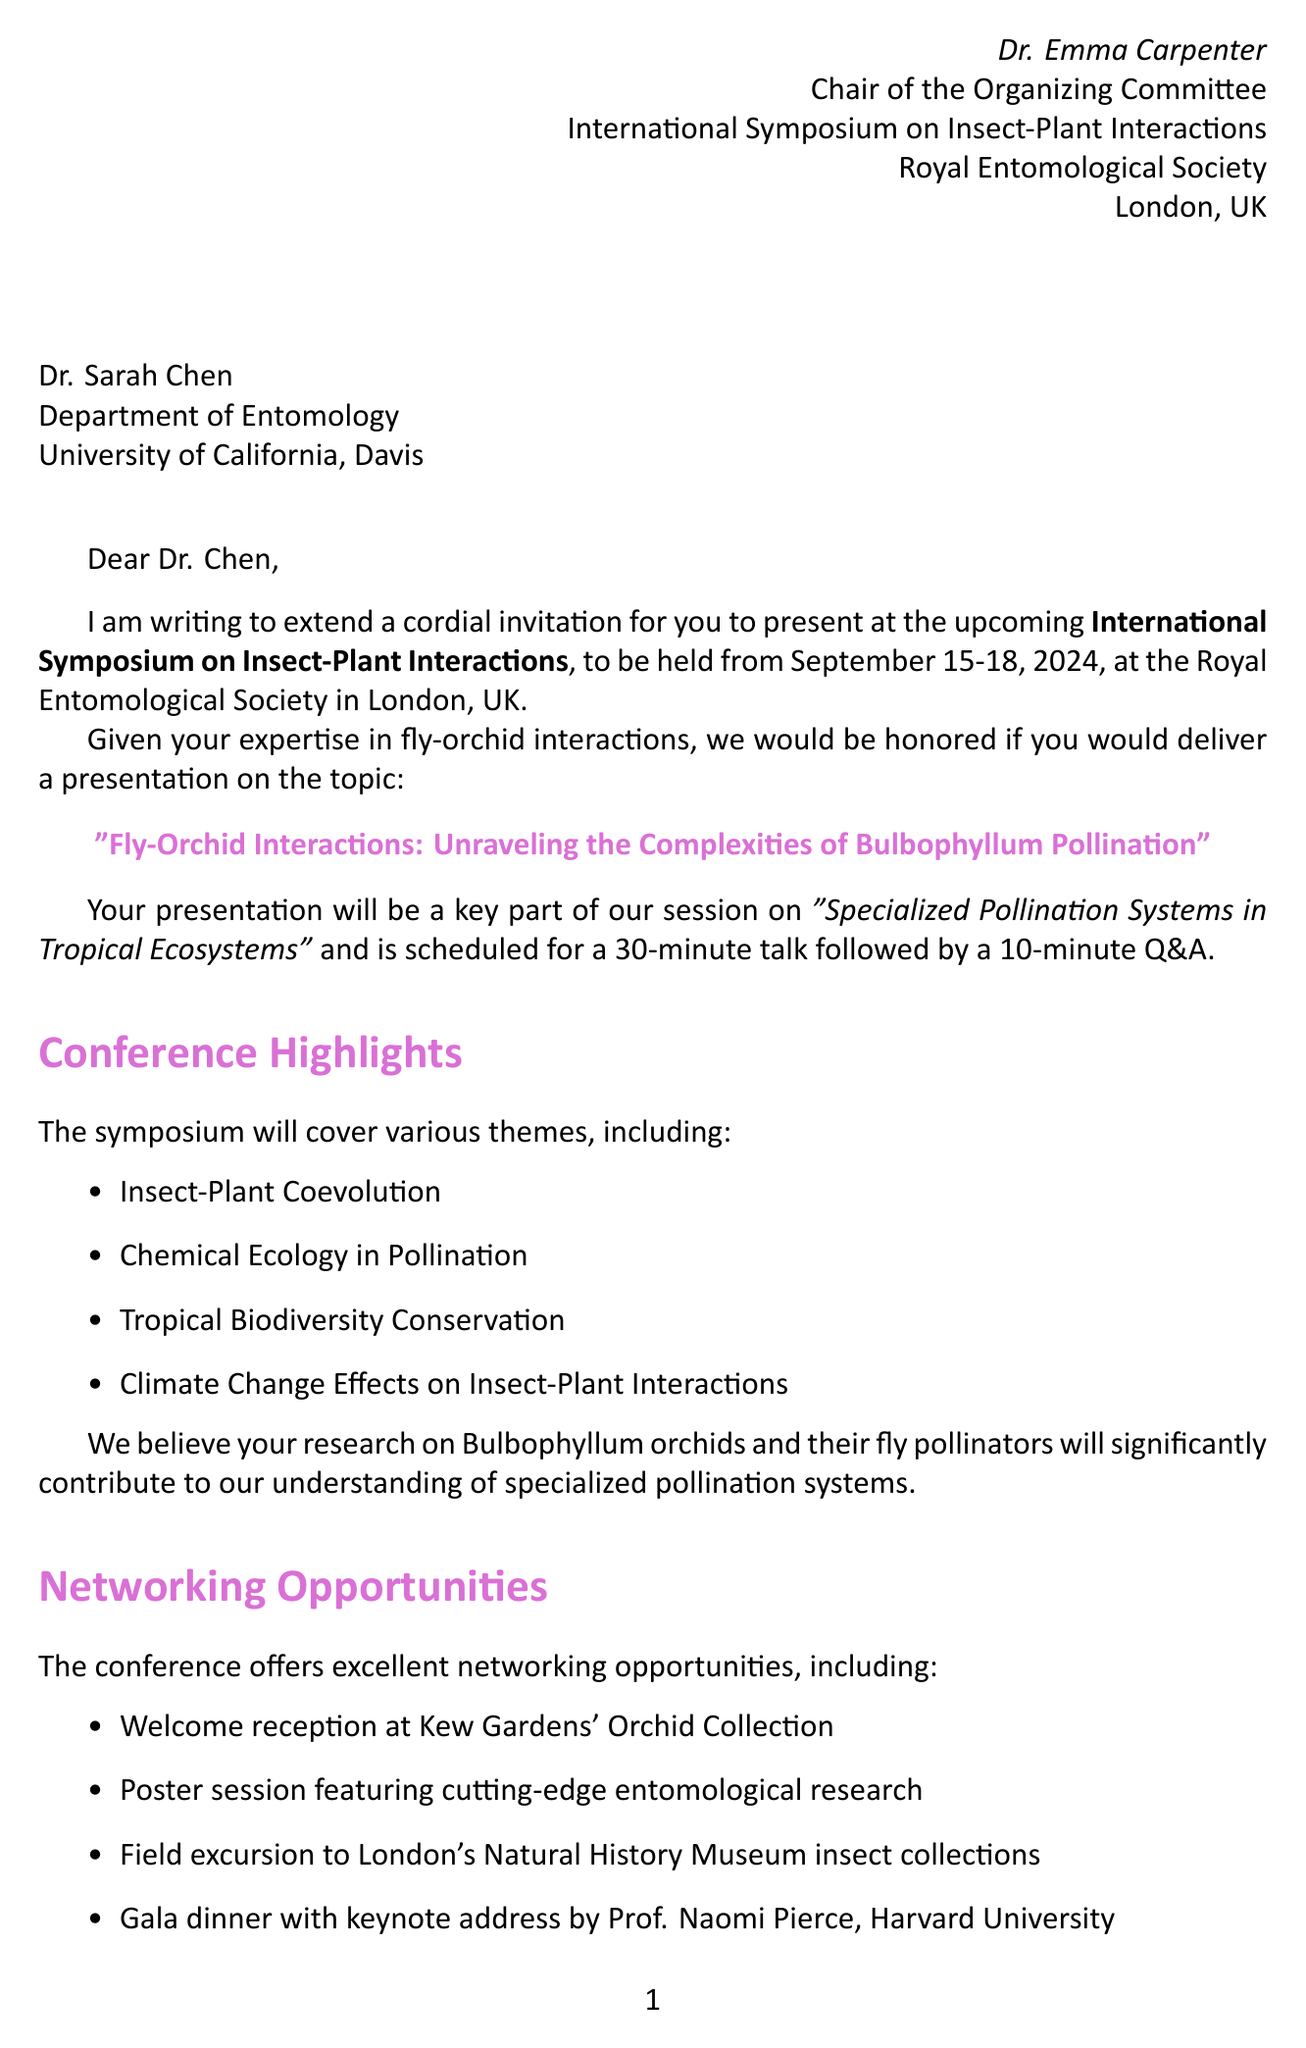What is the name of the conference? The name of the conference is stated in the document as the International Symposium on Insect-Plant Interactions.
Answer: International Symposium on Insect-Plant Interactions Who is the recipient of the invitation? The recipient of the invitation is mentioned at the beginning of the document as Dr. Sarah Chen.
Answer: Dr. Sarah Chen When is the deadline for abstract submission? The deadline for abstract submission is clearly indicated in the document as April 30, 2024.
Answer: April 30, 2024 What is the duration of the presentation? The duration of the presentation is specified in the document as 30 minutes, followed by a 10-minute Q&A.
Answer: 30 minutes What session will the presentation be a part of? The session for the presentation is noted in the document as "Specialized Pollination Systems in Tropical Ecosystems."
Answer: Specialized Pollination Systems in Tropical Ecosystems What is the nearest airport to the conference location? The nearest airport to the conference location is directly stated as London Heathrow Airport (LHR).
Answer: London Heathrow Airport (LHR) What publication opportunity is mentioned in the letter? The document mentions that selected presentations will be invited for submission to the Journal of Insect Science.
Answer: Journal of Insect Science Which hotel is recommended for attendees? The document lists The Rembrandt Hotel as one of the recommended hotels for attendees.
Answer: The Rembrandt Hotel Who is providing the keynote address? The keynote address is provided by Prof. Naomi Pierce, as specified in the networking opportunities section of the document.
Answer: Prof. Naomi Pierce 